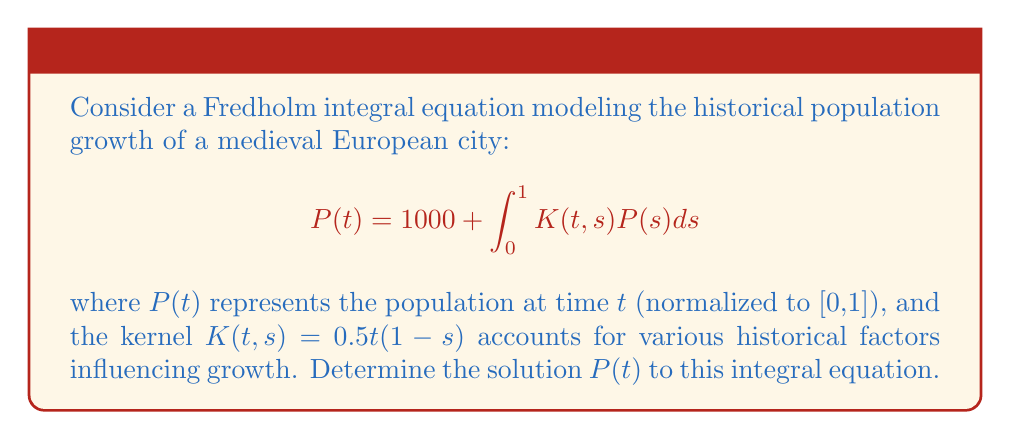Can you answer this question? To solve this Fredholm integral equation, we'll follow these steps:

1) First, we assume a solution of the form:
   $$P(t) = 1000 + at + bt^2$$
   where $a$ and $b$ are constants to be determined.

2) Substitute this into the right-hand side of the equation:
   $$1000 + \int_0^1 K(t,s)P(s)ds = 1000 + \int_0^1 0.5t(1-s)(1000 + as + bs^2)ds$$

3) Evaluate the integral:
   $$= 1000 + 0.5t\int_0^1 (1000 - 1000s + as - as^2 + bs^2 - bs^3)ds$$
   $$= 1000 + 0.5t[1000s - 500s^2 + \frac{1}{2}as^2 - \frac{1}{3}as^3 + \frac{1}{3}bs^3 - \frac{1}{4}bs^4]_0^1$$
   $$= 1000 + 0.5t(500 + \frac{1}{6}a + \frac{1}{12}b)$$

4) Equate this to our assumed solution:
   $$1000 + at + bt^2 = 1000 + 0.5t(500 + \frac{1}{6}a + \frac{1}{12}b)$$

5) Comparing coefficients of $t$ and $t^2$:
   $$a = 250 + \frac{1}{12}a + \frac{1}{24}b$$
   $$b = 0$$

6) From the second equation, we see that $b = 0$. Substituting this into the first equation:
   $$a = 250 + \frac{1}{12}a$$
   $$\frac{11}{12}a = 250$$
   $$a = \frac{3000}{11}$$

7) Therefore, the solution is:
   $$P(t) = 1000 + \frac{3000}{11}t$$
Answer: $P(t) = 1000 + \frac{3000}{11}t$ 